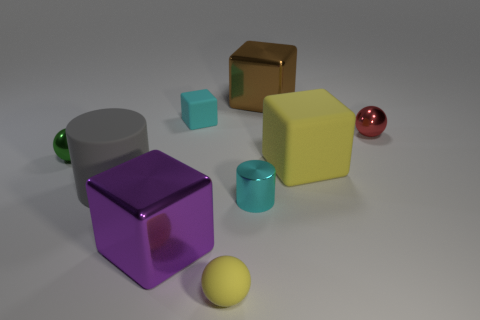Is there anything else that is made of the same material as the cyan cylinder?
Your answer should be compact. Yes. Is the number of cubes that are behind the tiny green metal object greater than the number of tiny blue rubber things?
Your answer should be very brief. Yes. Is the color of the tiny cylinder the same as the small matte cube?
Give a very brief answer. Yes. What number of other cyan objects are the same shape as the cyan matte object?
Keep it short and to the point. 0. The gray cylinder that is the same material as the large yellow object is what size?
Make the answer very short. Large. The shiny thing that is behind the purple metallic object and in front of the gray matte object is what color?
Offer a terse response. Cyan. What number of cyan metal objects are the same size as the yellow ball?
Ensure brevity in your answer.  1. There is a matte object that is the same color as the metallic cylinder; what is its size?
Provide a short and direct response. Small. There is a block that is both to the right of the tiny matte sphere and in front of the small cube; what size is it?
Make the answer very short. Large. There is a yellow object that is in front of the matte cube that is in front of the green object; how many matte blocks are to the left of it?
Ensure brevity in your answer.  1. 